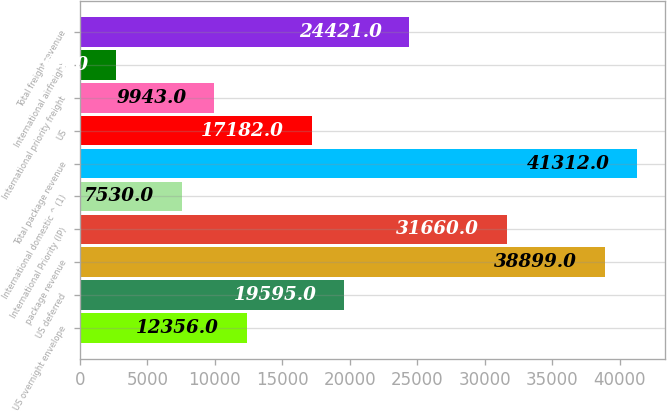Convert chart. <chart><loc_0><loc_0><loc_500><loc_500><bar_chart><fcel>US overnight envelope<fcel>US deferred<fcel>package revenue<fcel>International Priority (IP)<fcel>International domestic ^ (1)<fcel>Total package revenue<fcel>US<fcel>International priority freight<fcel>International airfreight<fcel>Total freight revenue<nl><fcel>12356<fcel>19595<fcel>38899<fcel>31660<fcel>7530<fcel>41312<fcel>17182<fcel>9943<fcel>2704<fcel>24421<nl></chart> 